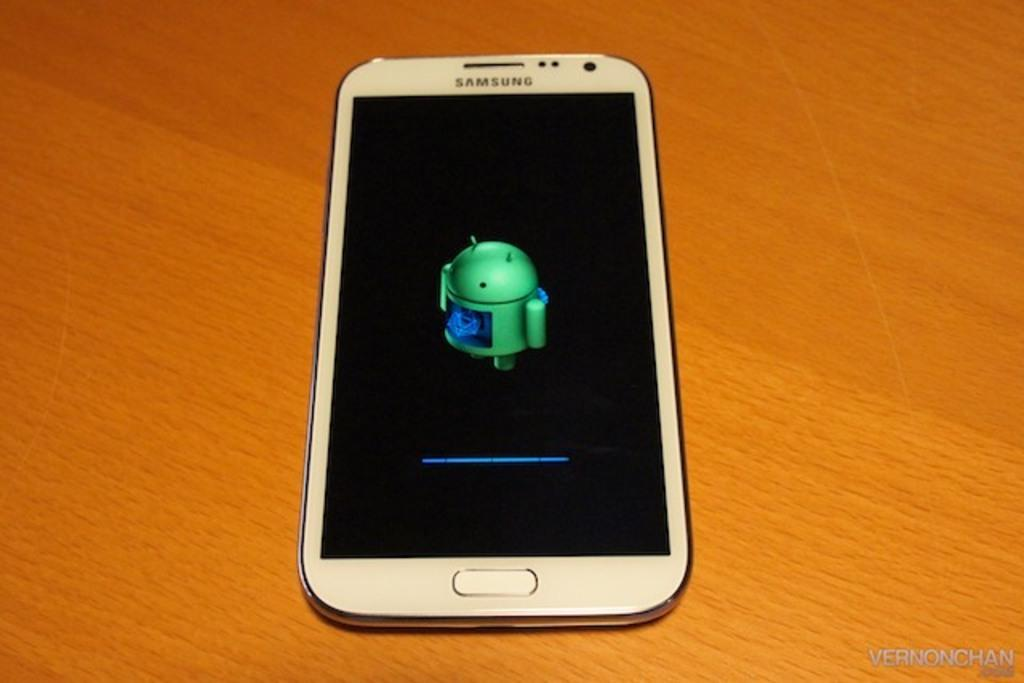<image>
Share a concise interpretation of the image provided. A white Samsung cell phone that is displaying a green Android symbol. 